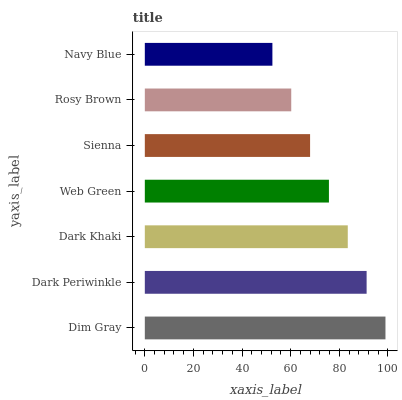Is Navy Blue the minimum?
Answer yes or no. Yes. Is Dim Gray the maximum?
Answer yes or no. Yes. Is Dark Periwinkle the minimum?
Answer yes or no. No. Is Dark Periwinkle the maximum?
Answer yes or no. No. Is Dim Gray greater than Dark Periwinkle?
Answer yes or no. Yes. Is Dark Periwinkle less than Dim Gray?
Answer yes or no. Yes. Is Dark Periwinkle greater than Dim Gray?
Answer yes or no. No. Is Dim Gray less than Dark Periwinkle?
Answer yes or no. No. Is Web Green the high median?
Answer yes or no. Yes. Is Web Green the low median?
Answer yes or no. Yes. Is Sienna the high median?
Answer yes or no. No. Is Dark Periwinkle the low median?
Answer yes or no. No. 